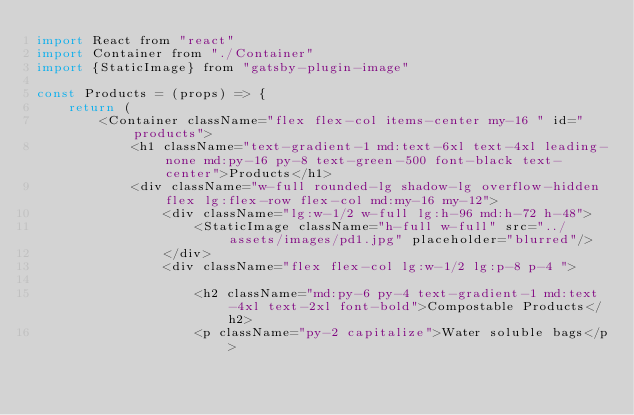Convert code to text. <code><loc_0><loc_0><loc_500><loc_500><_JavaScript_>import React from "react"
import Container from "./Container"
import {StaticImage} from "gatsby-plugin-image"

const Products = (props) => {
    return (
        <Container className="flex flex-col items-center my-16 " id="products">
            <h1 className="text-gradient-1 md:text-6xl text-4xl leading-none md:py-16 py-8 text-green-500 font-black text-center">Products</h1>
            <div className="w-full rounded-lg shadow-lg overflow-hidden flex lg:flex-row flex-col md:my-16 my-12">
                <div className="lg:w-1/2 w-full lg:h-96 md:h-72 h-48">
                    <StaticImage className="h-full w-full" src="../assets/images/pd1.jpg" placeholder="blurred"/>
                </div>
                <div className="flex flex-col lg:w-1/2 lg:p-8 p-4 ">
                
                    <h2 className="md:py-6 py-4 text-gradient-1 md:text-4xl text-2xl font-bold">Compostable Products</h2>
                    <p className="py-2 capitalize">Water soluble bags</p></code> 